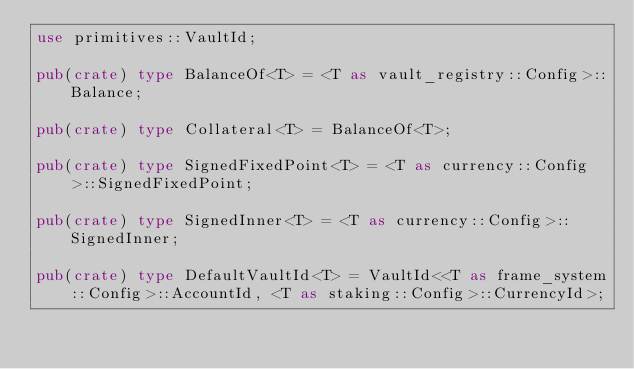Convert code to text. <code><loc_0><loc_0><loc_500><loc_500><_Rust_>use primitives::VaultId;

pub(crate) type BalanceOf<T> = <T as vault_registry::Config>::Balance;

pub(crate) type Collateral<T> = BalanceOf<T>;

pub(crate) type SignedFixedPoint<T> = <T as currency::Config>::SignedFixedPoint;

pub(crate) type SignedInner<T> = <T as currency::Config>::SignedInner;

pub(crate) type DefaultVaultId<T> = VaultId<<T as frame_system::Config>::AccountId, <T as staking::Config>::CurrencyId>;
</code> 